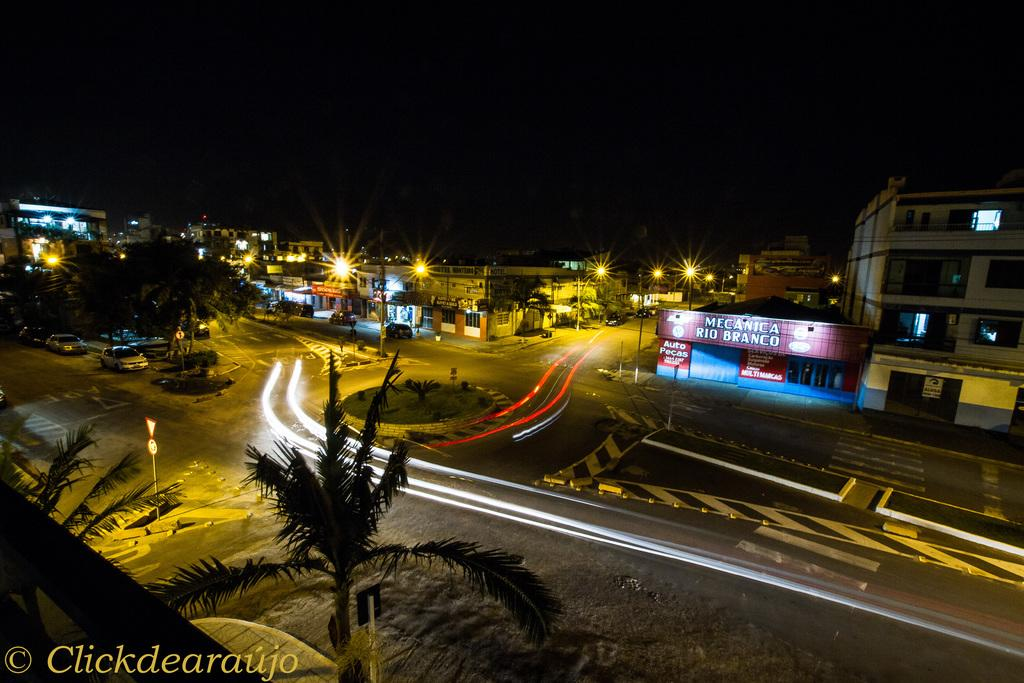What type of structures are present in the image? There are buildings in the image. What can be seen illuminating the scene in the image? There are lights in the image. What type of natural elements are present in the image? There are trees in the image. What type of transportation is visible on the roads in the image? There are vehicles on the roads in the image. How would you describe the overall lighting in the image? The background of the image is dark. Can you describe any additional elements present in the image? There is a watermark at the bottom left side of the image. Where is the market located in the image? There is no market present in the image. What type of cream is being used to decorate the trees in the image? There is no cream being used to decorate the trees in the image; they are natural trees. 